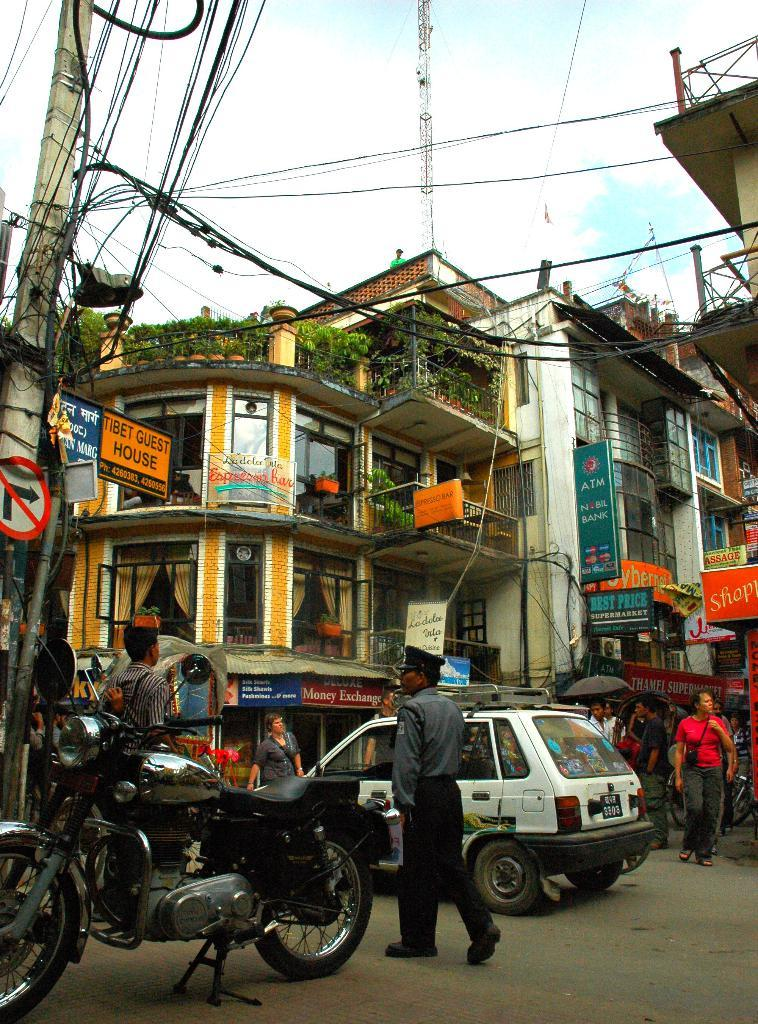How many people are in the image? There is a group of people in the image. What else can be seen in the image besides the people? There are vehicles, buildings, plants, boards, poles, and cables in the image. What is visible in the background of the image? The sky is visible in the background of the image. Who is the writer in the image? There is no writer present in the image. Can you tell me how many tickets are visible in the image? There is no mention of tickets in the image; the provided facts do not include any information about tickets. 